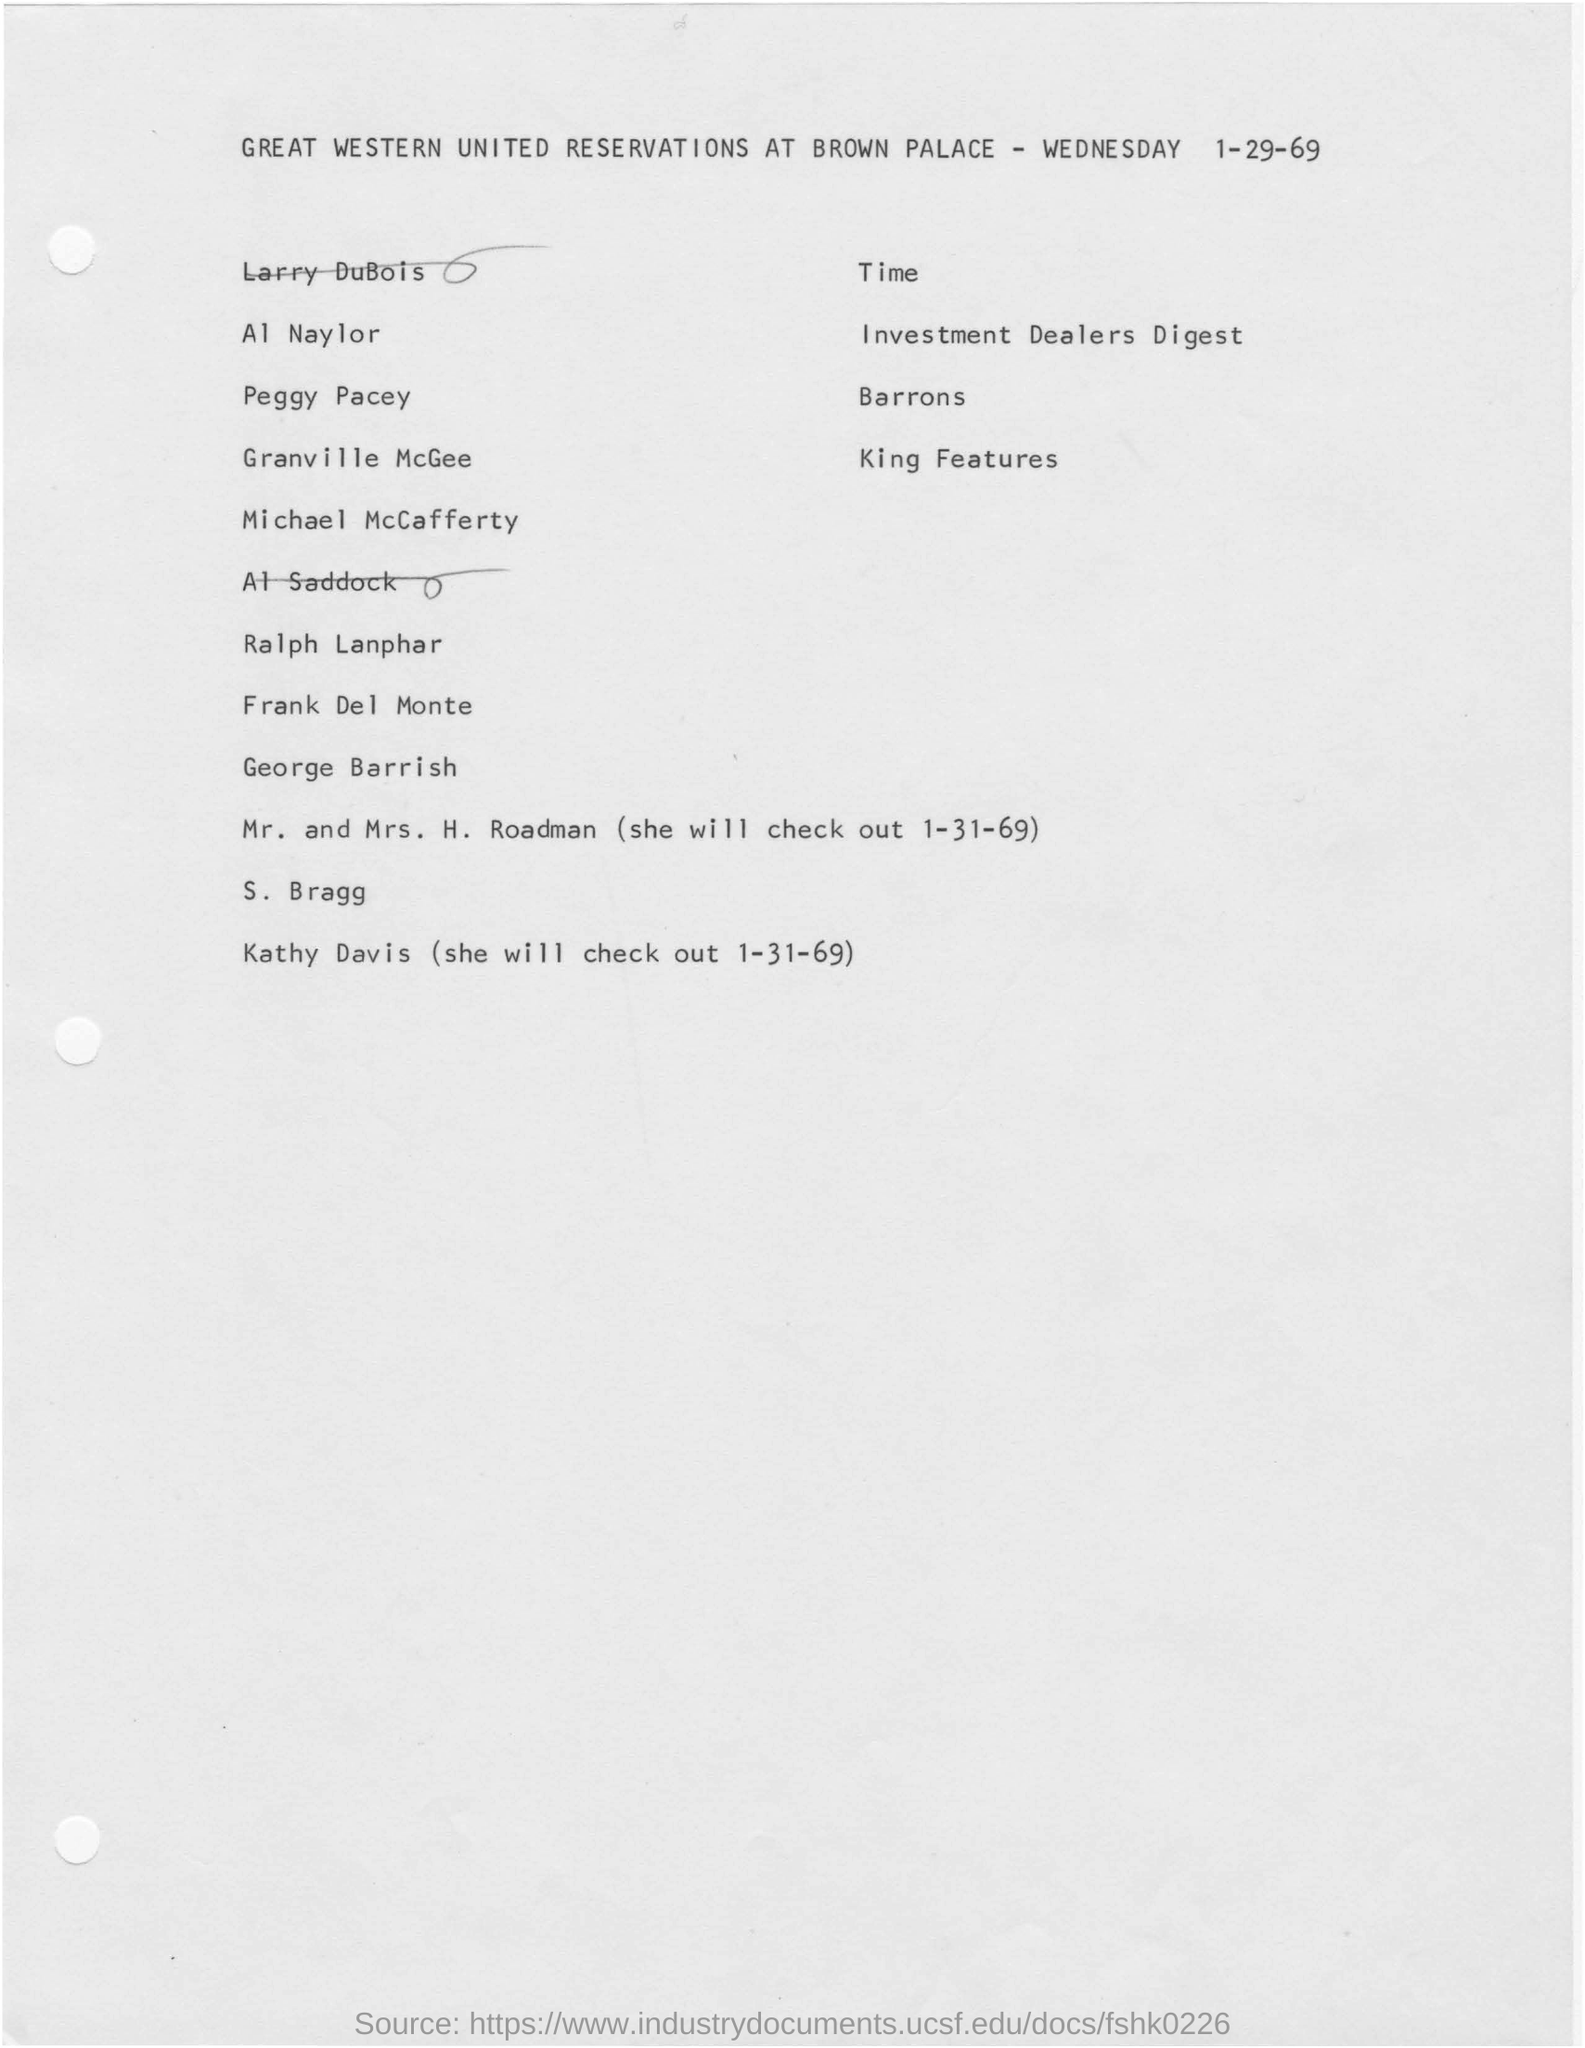What is the company name ?
Your response must be concise. GREAT WESTERN UNITED. What is the date mentioned in the top of the document ?
Offer a terse response. 1-29-69. Which week day mentioned in the document ?
Keep it short and to the point. Wednesday. What is the date mentioned in the bottom of the document ?
Provide a succinct answer. 1-31-69. What is the day mentioned in the given page ?
Offer a terse response. WEDNESDAY. 